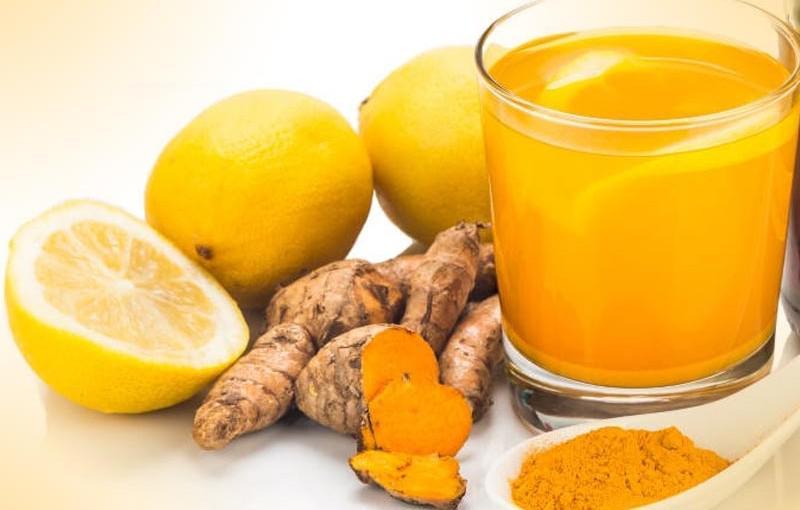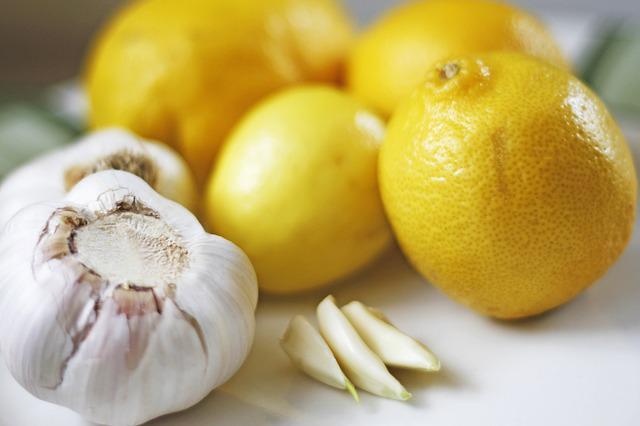The first image is the image on the left, the second image is the image on the right. Assess this claim about the two images: "The combined images include cut and whole lemons and a clear glass containing citrus juice.". Correct or not? Answer yes or no. Yes. 